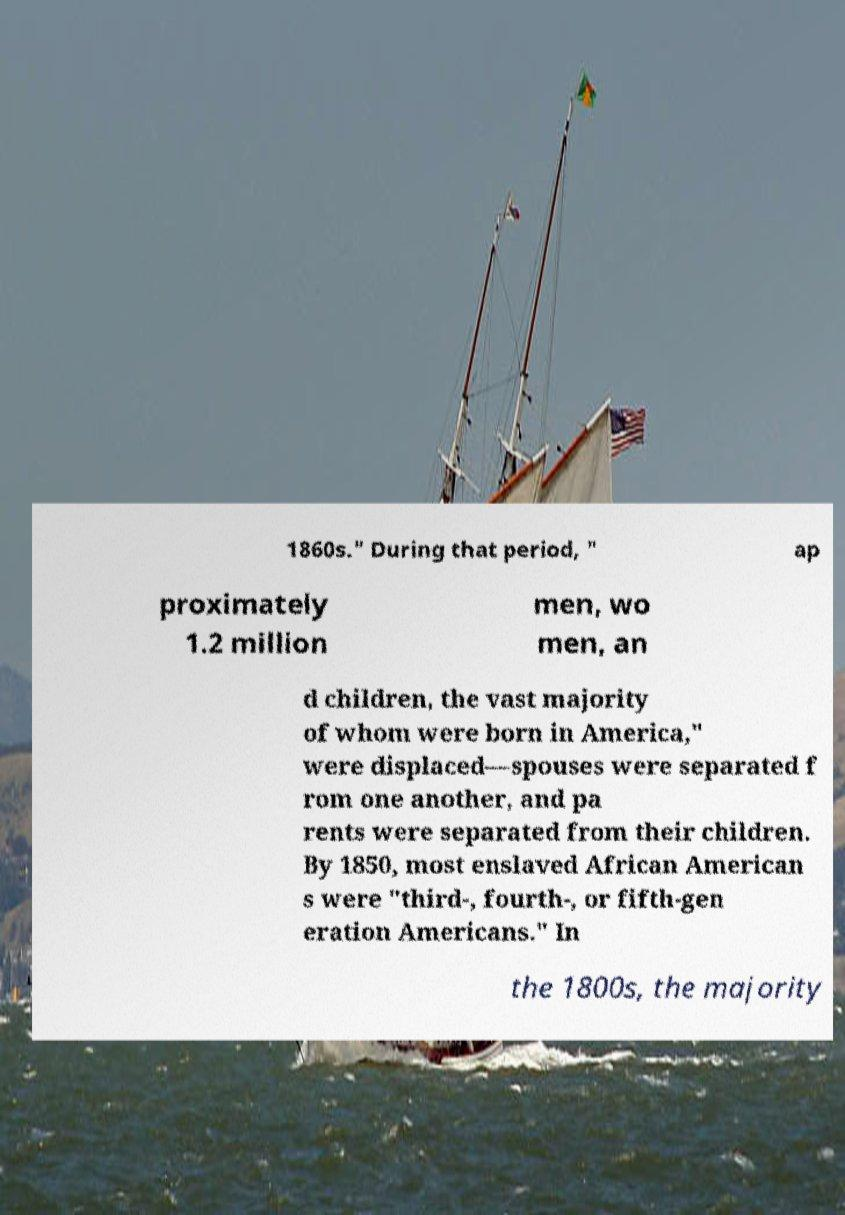There's text embedded in this image that I need extracted. Can you transcribe it verbatim? 1860s." During that period, " ap proximately 1.2 million men, wo men, an d children, the vast majority of whom were born in America," were displaced—spouses were separated f rom one another, and pa rents were separated from their children. By 1850, most enslaved African American s were "third-, fourth-, or fifth-gen eration Americans." In the 1800s, the majority 